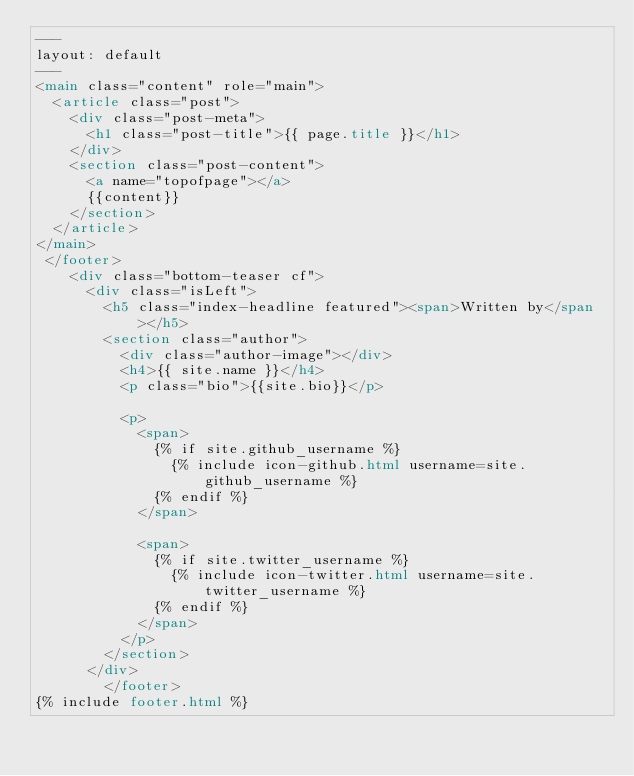<code> <loc_0><loc_0><loc_500><loc_500><_HTML_>---
layout: default
---
<main class="content" role="main">
  <article class="post">
    <div class="post-meta">
      <h1 class="post-title">{{ page.title }}</h1>
    </div>
    <section class="post-content">
      <a name="topofpage"></a>
      {{content}}
    </section>
  </article>
</main>
 </footer>
    <div class="bottom-teaser cf">
      <div class="isLeft">
        <h5 class="index-headline featured"><span>Written by</span></h5>
        <section class="author">
          <div class="author-image"></div>
          <h4>{{ site.name }}</h4>
          <p class="bio">{{site.bio}}</p>

          <p>
            <span>
              {% if site.github_username %}
                {% include icon-github.html username=site.github_username %}
              {% endif %}
            </span>

            <span>
              {% if site.twitter_username %}
                {% include icon-twitter.html username=site.twitter_username %}
              {% endif %}
            </span>
          </p>
        </section>
      </div>
        </footer>
{% include footer.html %}
</code> 